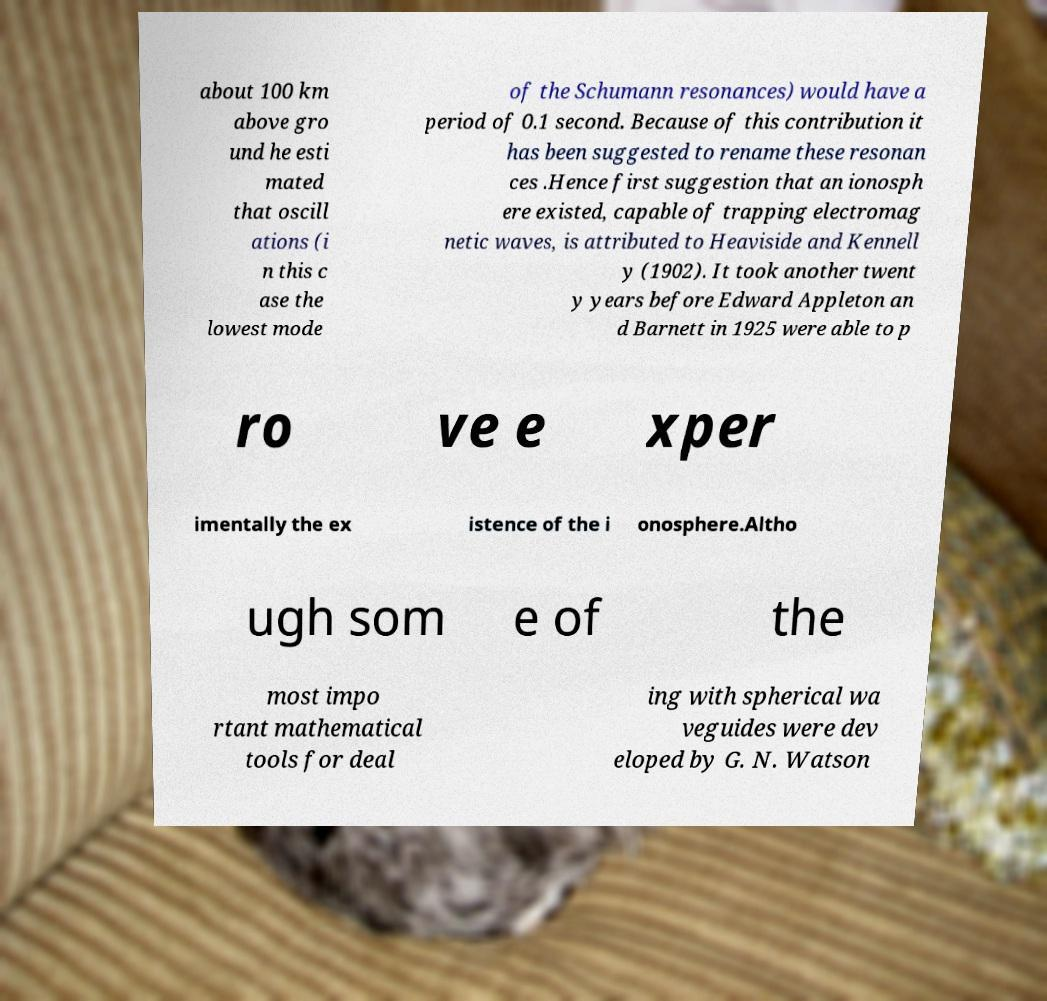Can you accurately transcribe the text from the provided image for me? about 100 km above gro und he esti mated that oscill ations (i n this c ase the lowest mode of the Schumann resonances) would have a period of 0.1 second. Because of this contribution it has been suggested to rename these resonan ces .Hence first suggestion that an ionosph ere existed, capable of trapping electromag netic waves, is attributed to Heaviside and Kennell y (1902). It took another twent y years before Edward Appleton an d Barnett in 1925 were able to p ro ve e xper imentally the ex istence of the i onosphere.Altho ugh som e of the most impo rtant mathematical tools for deal ing with spherical wa veguides were dev eloped by G. N. Watson 